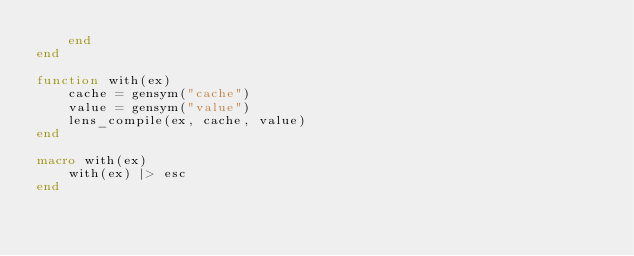<code> <loc_0><loc_0><loc_500><loc_500><_Julia_>    end
end

function with(ex)
    cache = gensym("cache")
    value = gensym("value")
    lens_compile(ex, cache, value)
end

macro with(ex)
    with(ex) |> esc
end</code> 